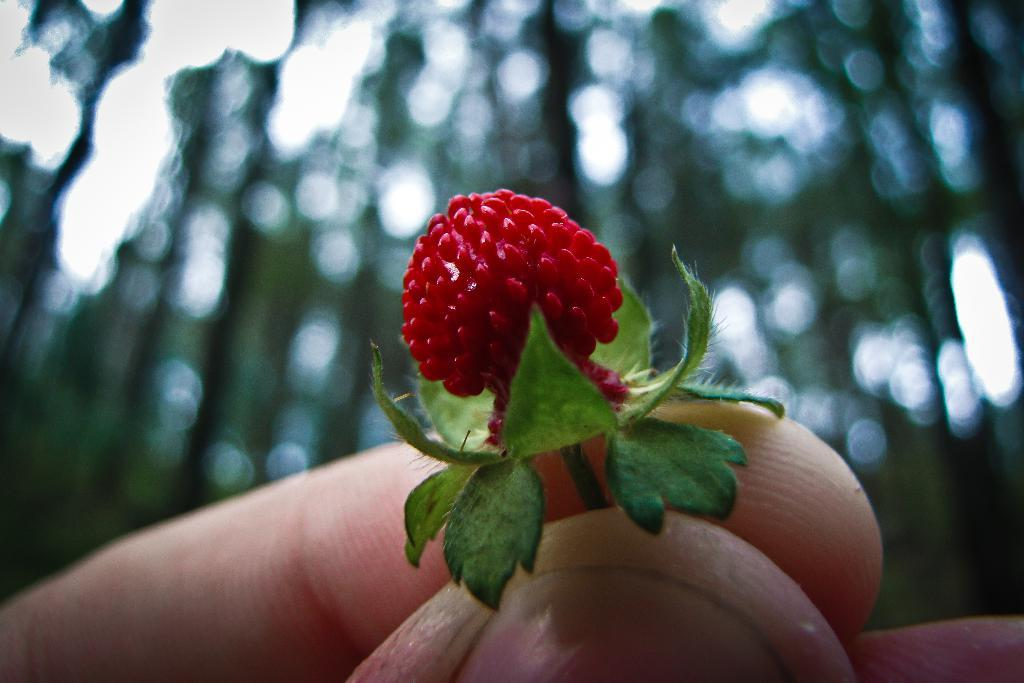What can be seen in the person's hand in the image? The hand is holding a red flower. What else can be observed about the flower? The flower has leaves. Can you describe the background of the image? The background of the image is blurred. What is the name of the downtown street visible in the background of the image? There is no downtown street visible in the background of the image; the background is blurred. How does the moon appear in the image? The moon is not present in the image; it only features a person's hand holding a red flower. 